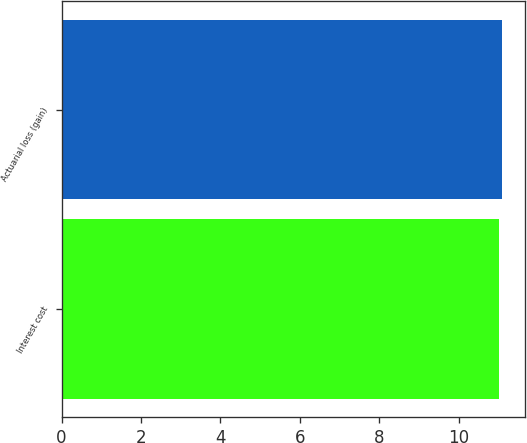<chart> <loc_0><loc_0><loc_500><loc_500><bar_chart><fcel>Interest cost<fcel>Actuarial loss (gain)<nl><fcel>11<fcel>11.1<nl></chart> 